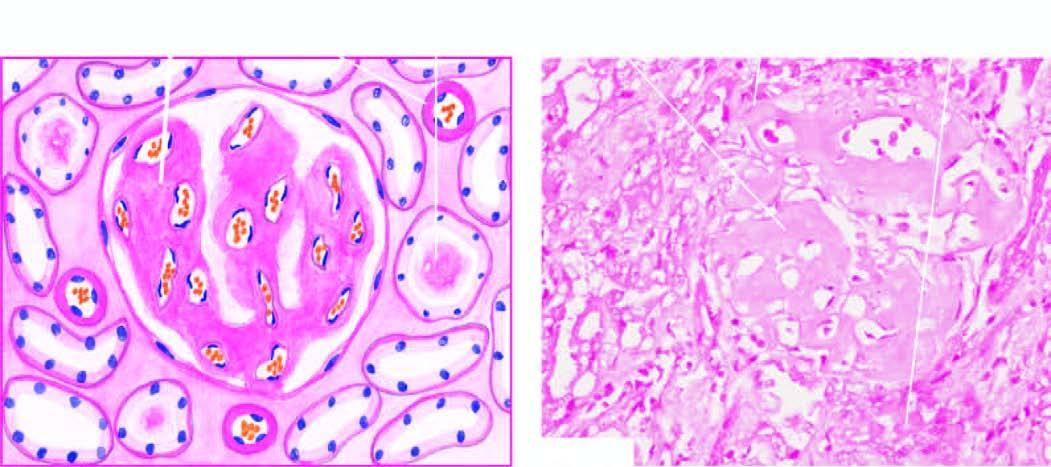where are the amyloid deposits seen?
Answer the question using a single word or phrase. Glomerular capillary tuft 